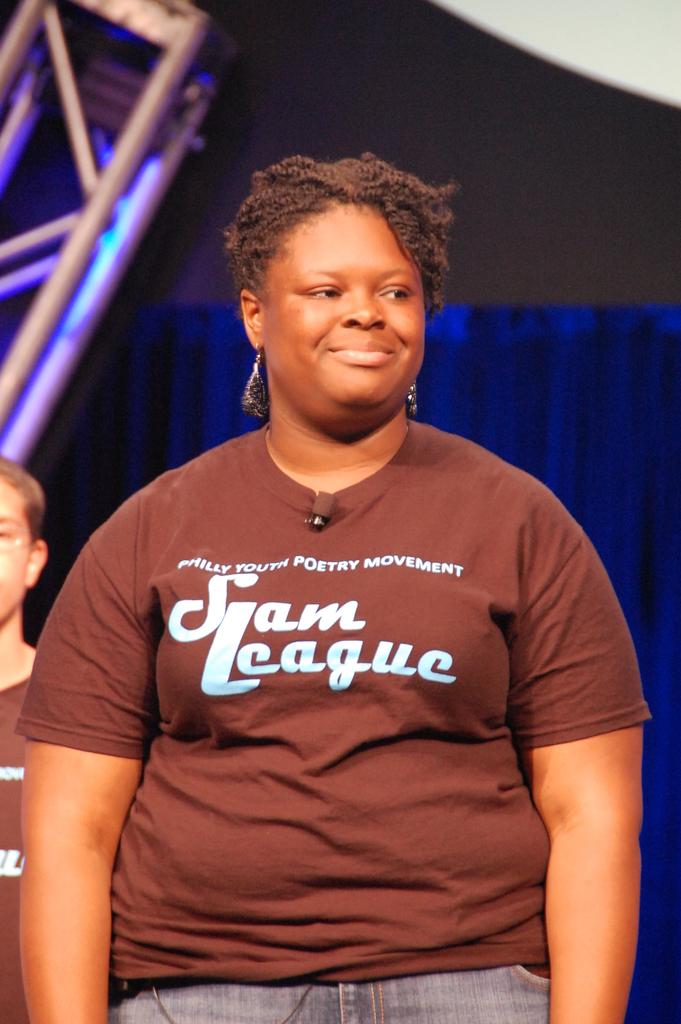What type of league is it?
Offer a terse response. Slam. What kind of movement is going on in the photo?
Your answer should be very brief. Poetry. 